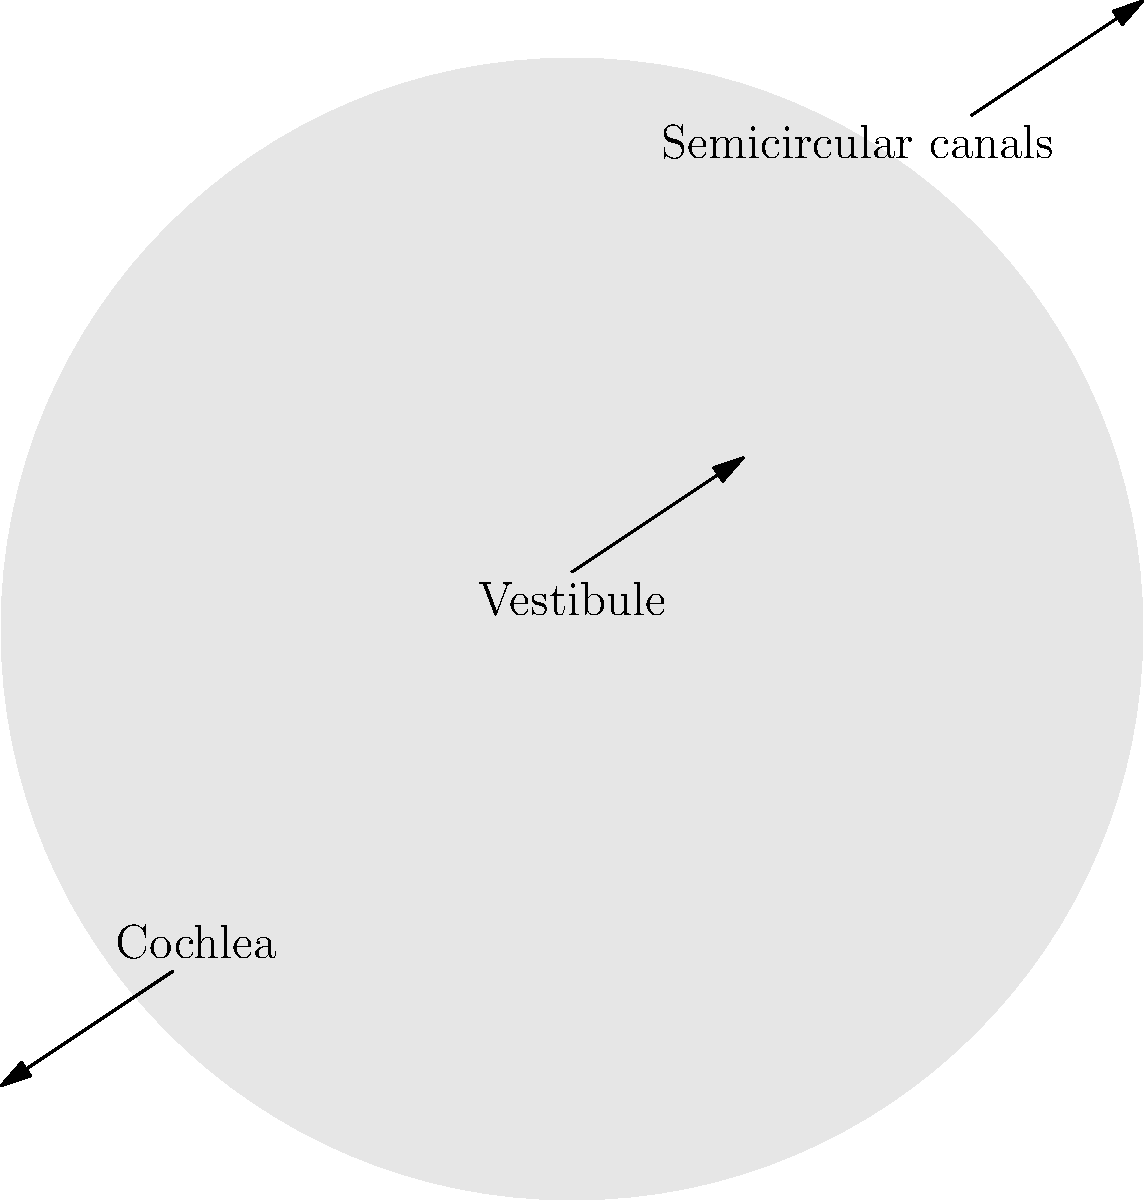In the cross-sectional diagram of the inner ear shown above, which structure is responsible for converting sound waves into electrical signals that can be interpreted by the brain? To answer this question, let's break down the components of the inner ear and their functions:

1. Semicircular canals: These are responsible for detecting rotational movements of the head and maintaining balance. They do not play a direct role in hearing.

2. Vestibule: This is the central part of the inner ear that contains the utricle and saccule. These structures are primarily involved in detecting linear acceleration and head position with respect to gravity. They are not directly involved in sound perception.

3. Cochlea: This is the spiral-shaped structure in the inner ear that is crucial for hearing. It contains:
   a) The organ of Corti, which houses the hair cells
   b) The basilar membrane, which vibrates in response to sound waves
   c) The tectorial membrane, which interacts with the hair cells

The process of converting sound waves to electrical signals occurs as follows:
1. Sound waves enter the ear and cause the eardrum to vibrate
2. These vibrations are transmitted through the middle ear bones to the cochlea
3. The vibrations cause the fluid in the cochlea to move, which in turn causes the basilar membrane to vibrate
4. The movement of the basilar membrane causes the hair cells in the organ of Corti to bend against the tectorial membrane
5. This bending of the hair cells triggers the release of neurotransmitters, which generate electrical signals in the auditory nerve

Therefore, the cochlea is the structure responsible for converting sound waves into electrical signals that can be interpreted by the brain.
Answer: Cochlea 